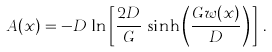Convert formula to latex. <formula><loc_0><loc_0><loc_500><loc_500>A ( x ) = - D \, \ln \left [ \frac { 2 D } { G } \, \sinh \left ( \frac { G w ( x ) } { D } \right ) \, \right ] \, .</formula> 